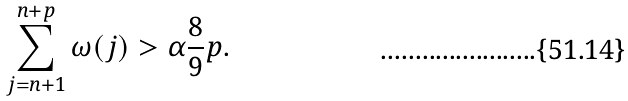<formula> <loc_0><loc_0><loc_500><loc_500>\sum _ { j = n + 1 } ^ { n + p } \omega ( j ) > \alpha \frac { 8 } { 9 } p .</formula> 